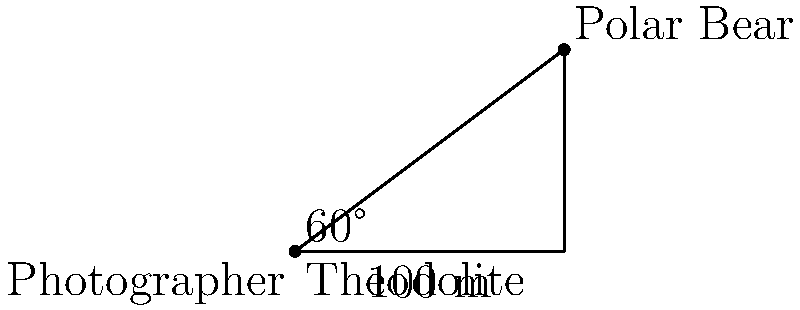While on an Arctic expedition, you spot a polar bear in the distance. Using your theodolite, you measure the angle of elevation to the bear as 60°. The horizontal distance to the bear is 100 meters. What is the actual distance between you and the polar bear? To solve this problem, we'll use trigonometry, specifically the tangent function. Let's break it down step-by-step:

1) We have a right triangle where:
   - The adjacent side (horizontal distance) is 100 meters
   - The angle of elevation is 60°
   - We need to find the hypotenuse (actual distance to the bear)

2) In a right triangle, $\tan(\theta) = \frac{\text{opposite}}{\text{adjacent}}$

3) We can use this to find the height (opposite side):
   $\tan(60°) = \frac{\text{height}}{100}$

4) $\tan(60°) = \sqrt{3} \approx 1.732$

5) Solving for height:
   $\text{height} = 100 \times \tan(60°) = 100 \times \sqrt{3} \approx 173.2$ meters

6) Now we have a right triangle where we know:
   - The adjacent side (100 m)
   - The opposite side (173.2 m)

7) We can use the Pythagorean theorem to find the hypotenuse:
   $c^2 = a^2 + b^2$
   $c^2 = 100^2 + 173.2^2$
   $c^2 = 10000 + 30000.24 = 40000.24$
   $c = \sqrt{40000.24} \approx 200$ meters

Therefore, the actual distance to the polar bear is approximately 200 meters.
Answer: 200 meters 